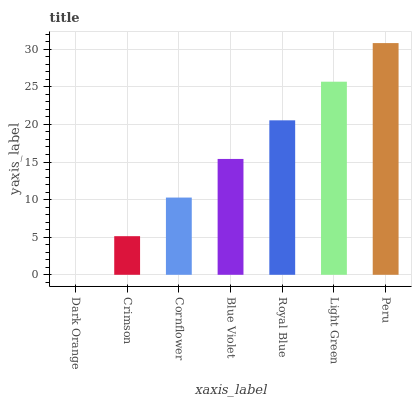Is Dark Orange the minimum?
Answer yes or no. Yes. Is Peru the maximum?
Answer yes or no. Yes. Is Crimson the minimum?
Answer yes or no. No. Is Crimson the maximum?
Answer yes or no. No. Is Crimson greater than Dark Orange?
Answer yes or no. Yes. Is Dark Orange less than Crimson?
Answer yes or no. Yes. Is Dark Orange greater than Crimson?
Answer yes or no. No. Is Crimson less than Dark Orange?
Answer yes or no. No. Is Blue Violet the high median?
Answer yes or no. Yes. Is Blue Violet the low median?
Answer yes or no. Yes. Is Light Green the high median?
Answer yes or no. No. Is Cornflower the low median?
Answer yes or no. No. 